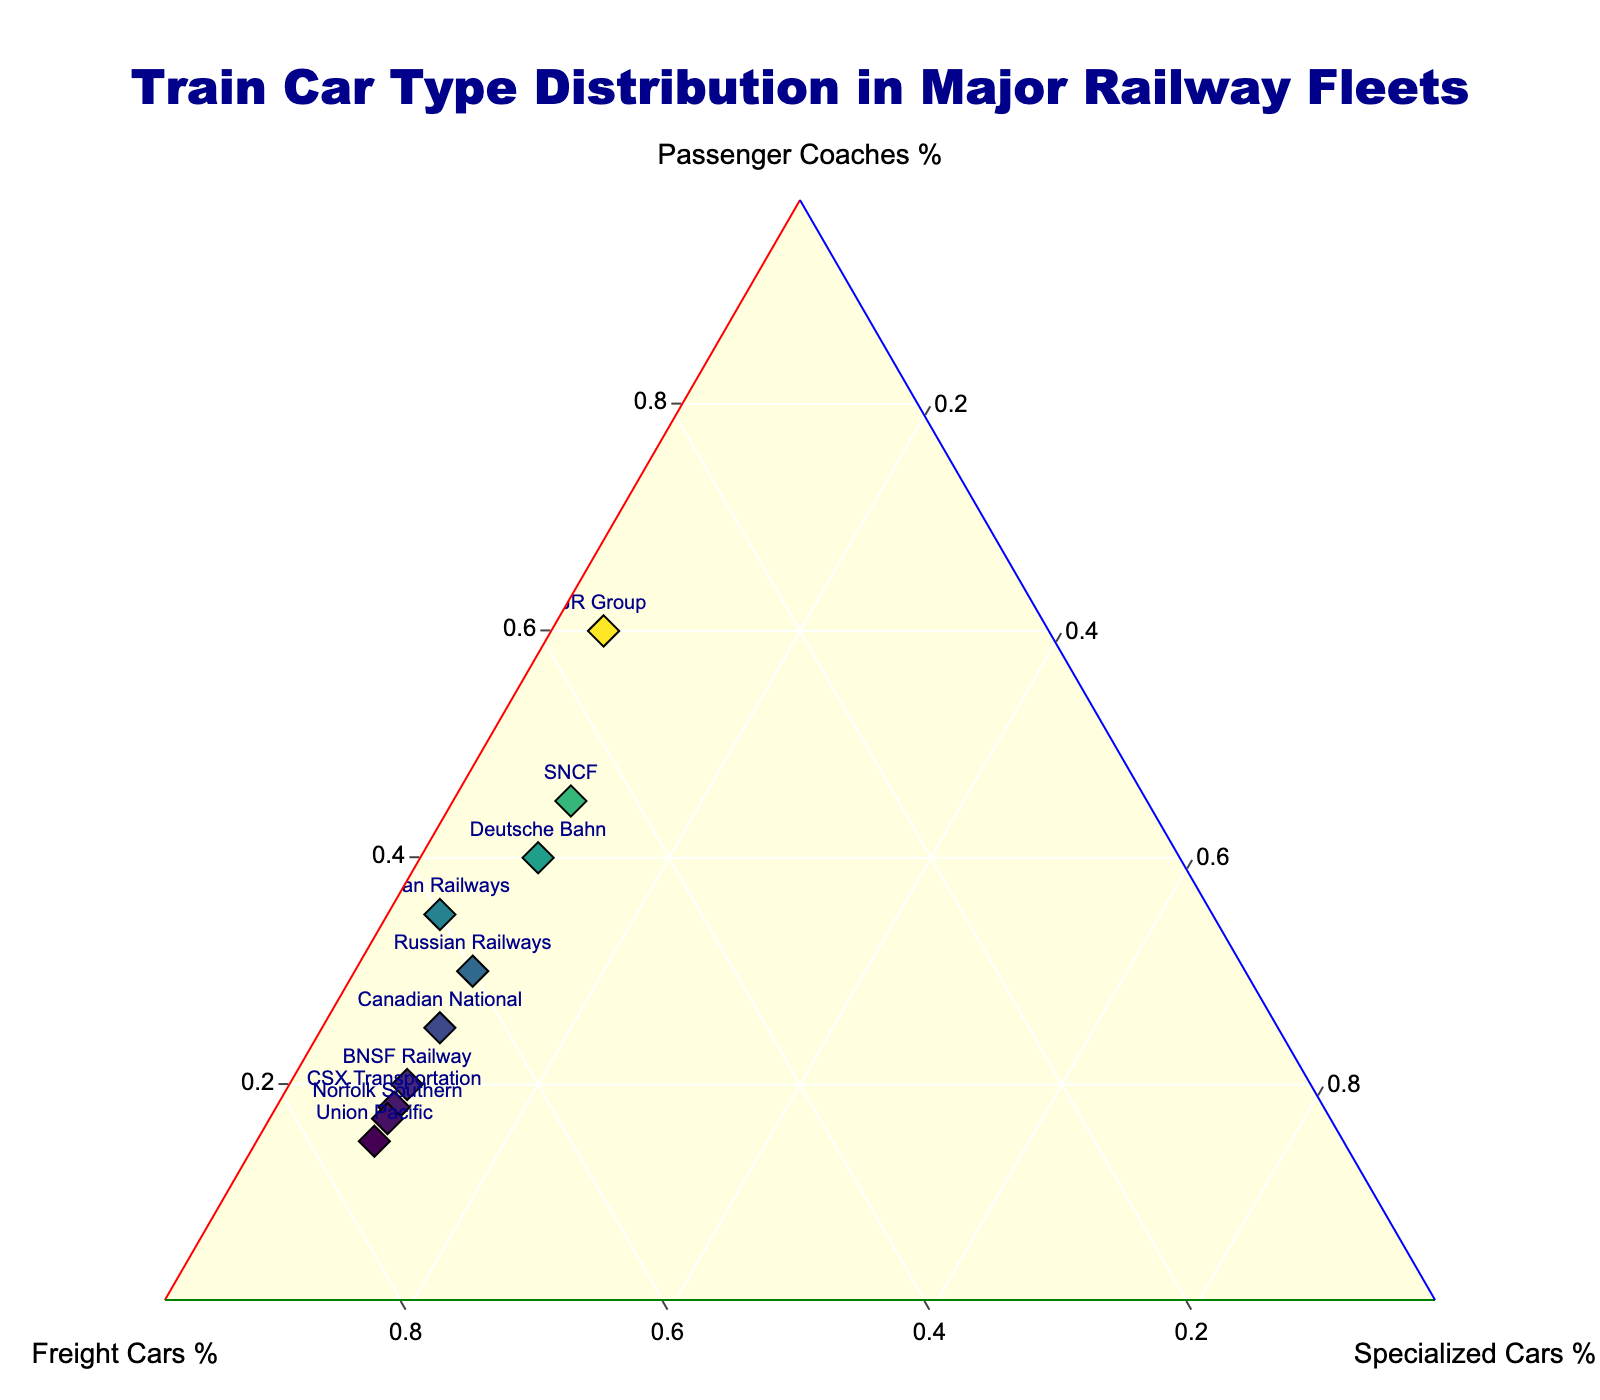What is the title of the plot? The title of the plot is usually placed at the top and centered. It provides a summary of what the figure is showing.
Answer: Train Car Type Distribution in Major Railway Fleets How many railway fleets are represented in the plot? Each point on the plot represents a different railway fleet. Counting these points will give the total number of railway fleets.
Answer: 10 Which railway has the highest percentage of passenger coaches? The highest percentage of passenger coaches corresponds to the point farthest along the 'Passenger Coaches %' axis.
Answer: JR Group Which railway has an equal percentage of passenger coaches and freight cars? To find a railway with equal percentages, look for a point equidistant from the 'Passenger Coaches %' and 'Freight Cars %' axes.
Answer: SNCF What percentage of specialized cars does Indian Railways have? Hovering over the point for Indian Railways will show the specific percentages for passenger coaches, freight cars, and specialized cars.
Answer: 5% Which railways have an equal percentage of specialized cars? Points that are at the same level on the 'Specialized Cars %' axis have equal percentages of specialized cars.
Answer: Union Pacific, BNSF Railway, CSX Transportation, Norfolk Southern, Canadian National, Deutsche Bahn, SNCF, Russian Railways Compare the proportion of freight cars between JR Group and Deutsche Bahn. The 'Freight Cars %' can be compared directly by looking at the relative positions of their points along the 'Freight Cars %' axis.
Answer: Deutsche Bahn has a higher percentage of freight cars than JR Group How does the distribution of Russian Railways compare to Indian Railways? Comparing distributions involves looking at the positions of points relative to 'Passenger Coaches %', 'Freight Cars %', and 'Specialized Cars %'. Russian Railways has more passenger coaches and specialized cars, whereas Indian Railways has a higher percentage of freight cars.
Answer: Russian Railways has 30% passenger coaches, 60% freight cars, and 10% specialized cars. Indian Railways has 35% passenger coaches, 60% freight cars, and 5% specialized cars Which railway has the most balanced distribution of train car types? 'Balanced distribution' means that the point is close to the center of the ternary plot, indicating similar percentages for all three types of cars.
Answer: SNCF 